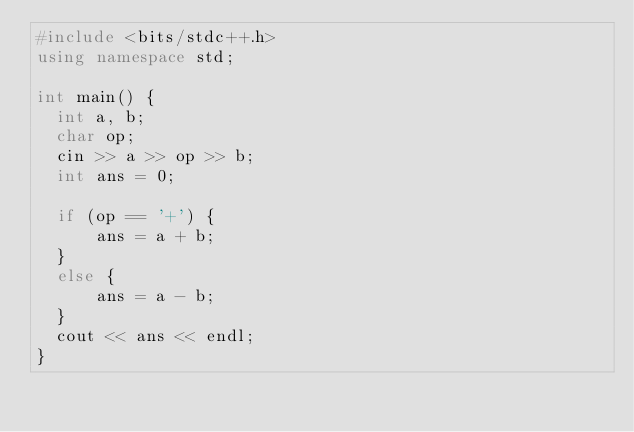<code> <loc_0><loc_0><loc_500><loc_500><_C++_>#include <bits/stdc++.h>
using namespace std;
 
int main() {
  int a, b;
  char op;
  cin >> a >> op >> b;
  int ans = 0;

  if (op == '+') {
      ans = a + b;
  }
  else {
      ans = a - b;
  }
  cout << ans << endl;
}</code> 